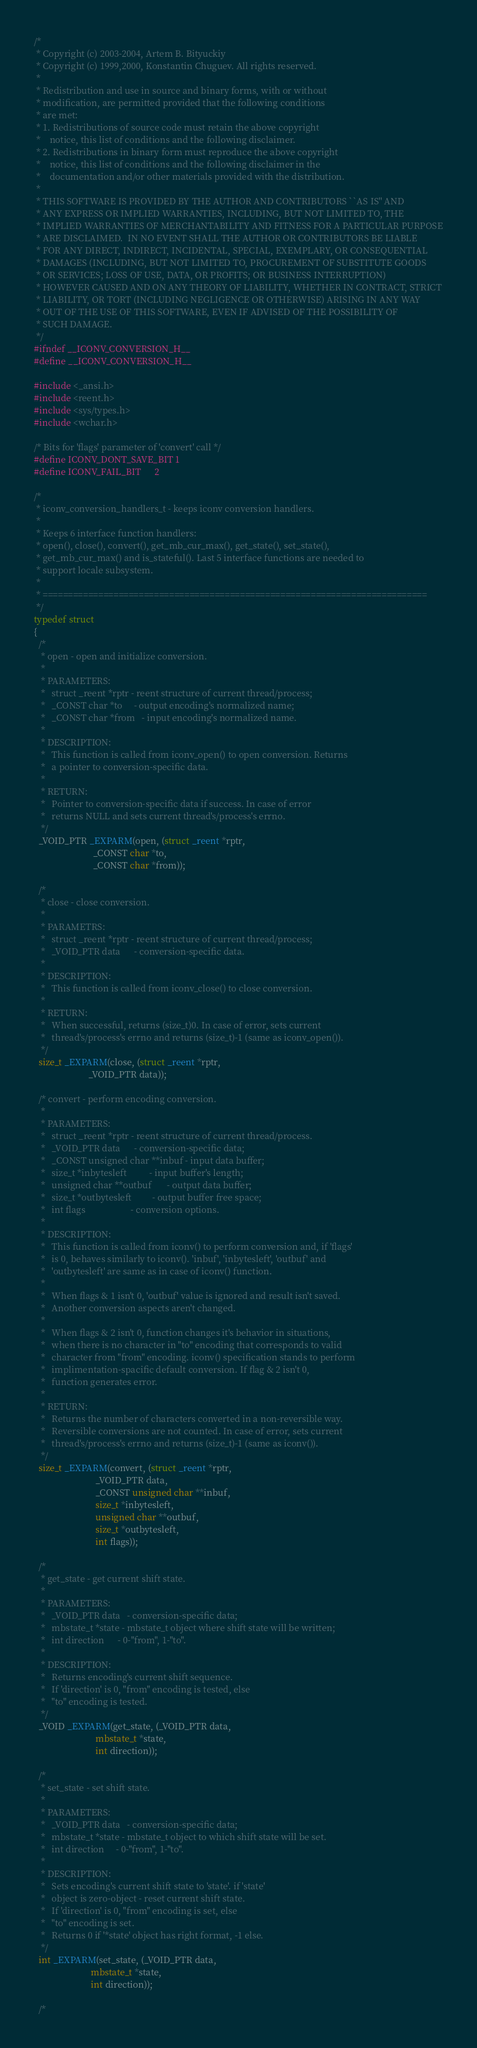<code> <loc_0><loc_0><loc_500><loc_500><_C_>/*
 * Copyright (c) 2003-2004, Artem B. Bityuckiy
 * Copyright (c) 1999,2000, Konstantin Chuguev. All rights reserved.
 *
 * Redistribution and use in source and binary forms, with or without
 * modification, are permitted provided that the following conditions
 * are met:
 * 1. Redistributions of source code must retain the above copyright
 *    notice, this list of conditions and the following disclaimer.
 * 2. Redistributions in binary form must reproduce the above copyright
 *    notice, this list of conditions and the following disclaimer in the
 *    documentation and/or other materials provided with the distribution.
 *
 * THIS SOFTWARE IS PROVIDED BY THE AUTHOR AND CONTRIBUTORS ``AS IS'' AND
 * ANY EXPRESS OR IMPLIED WARRANTIES, INCLUDING, BUT NOT LIMITED TO, THE
 * IMPLIED WARRANTIES OF MERCHANTABILITY AND FITNESS FOR A PARTICULAR PURPOSE
 * ARE DISCLAIMED.  IN NO EVENT SHALL THE AUTHOR OR CONTRIBUTORS BE LIABLE
 * FOR ANY DIRECT, INDIRECT, INCIDENTAL, SPECIAL, EXEMPLARY, OR CONSEQUENTIAL
 * DAMAGES (INCLUDING, BUT NOT LIMITED TO, PROCUREMENT OF SUBSTITUTE GOODS
 * OR SERVICES; LOSS OF USE, DATA, OR PROFITS; OR BUSINESS INTERRUPTION)
 * HOWEVER CAUSED AND ON ANY THEORY OF LIABILITY, WHETHER IN CONTRACT, STRICT
 * LIABILITY, OR TORT (INCLUDING NEGLIGENCE OR OTHERWISE) ARISING IN ANY WAY
 * OUT OF THE USE OF THIS SOFTWARE, EVEN IF ADVISED OF THE POSSIBILITY OF
 * SUCH DAMAGE.
 */
#ifndef __ICONV_CONVERSION_H__
#define __ICONV_CONVERSION_H__

#include <_ansi.h>
#include <reent.h>
#include <sys/types.h>
#include <wchar.h>

/* Bits for 'flags' parameter of 'convert' call */
#define ICONV_DONT_SAVE_BIT 1
#define ICONV_FAIL_BIT      2

/*
 * iconv_conversion_handlers_t - keeps iconv conversion handlers.
 *
 * Keeps 6 interface function handlers:
 * open(), close(), convert(), get_mb_cur_max(), get_state(), set_state(),
 * get_mb_cur_max() and is_stateful(). Last 5 interface functions are needed to
 * support locale subsystem.
 *
 * ============================================================================
 */
typedef struct
{
  /*
   * open - open and initialize conversion.
   *
   * PARAMETERS:
   *   struct _reent *rptr - reent structure of current thread/process;
   *   _CONST char *to     - output encoding's normalized name;
   *   _CONST char *from   - input encoding's normalized name.
   * 
   * DESCRIPTION:
   *   This function is called from iconv_open() to open conversion. Returns
   *   a pointer to conversion-specific data.
   *
   * RETURN:
   *   Pointer to conversion-specific data if success. In case of error
   *   returns NULL and sets current thread's/process's errno.
   */
  _VOID_PTR _EXPARM(open, (struct _reent *rptr,
                          _CONST char *to,
                          _CONST char *from));
  
  /*
   * close - close conversion.
   *
   * PARAMETRS:
   *   struct _reent *rptr - reent structure of current thread/process;
   *   _VOID_PTR data      - conversion-specific data.
   *
   * DESCRIPTION:
   *   This function is called from iconv_close() to close conversion.
   *
   * RETURN:
   *   When successful, returns (size_t)0. In case of error, sets current
   *   thread's/process's errno and returns (size_t)-1 (same as iconv_open()).
   */
  size_t _EXPARM(close, (struct _reent *rptr,
                        _VOID_PTR data));
  
  /* convert - perform encoding conversion.
   *
   * PARAMETERS:
   *   struct _reent *rptr - reent structure of current thread/process.
   *   _VOID_PTR data      - conversion-specific data;
   *   _CONST unsigned char **inbuf - input data buffer;
   *   size_t *inbytesleft          - input buffer's length;
   *   unsigned char **outbuf       - output data buffer;
   *   size_t *outbytesleft         - output buffer free space;
   *   int flags                    - conversion options.
   *
   * DESCRIPTION:
   *   This function is called from iconv() to perform conversion and, if 'flags'
   *   is 0, behaves similarly to iconv(). 'inbuf', 'inbytesleft', 'outbuf' and
   *   'outbytesleft' are same as in case of iconv() function.
   *
   *   When flags & 1 isn't 0, 'outbuf' value is ignored and result isn't saved.
   *   Another conversion aspects aren't changed.
   *
   *   When flags & 2 isn't 0, function changes it's behavior in situations,
   *   when there is no character in "to" encoding that corresponds to valid
   *   character from "from" encoding. iconv() specification stands to perform
   *   implimentation-spacific default conversion. If flag & 2 isn't 0,
   *   function generates error.
   *
   * RETURN:
   *   Returns the number of characters converted in a non-reversible way.
   *   Reversible conversions are not counted. In case of error, sets current
   *   thread's/process's errno and returns (size_t)-1 (same as iconv()).
   */
  size_t _EXPARM(convert, (struct _reent *rptr,
                           _VOID_PTR data,
                           _CONST unsigned char **inbuf,
                           size_t *inbytesleft,
                           unsigned char **outbuf,
                           size_t *outbytesleft,
                           int flags));
  
  /*
   * get_state - get current shift state.
   *
   * PARAMETERS:
   *   _VOID_PTR data   - conversion-specific data;
   *   mbstate_t *state - mbstate_t object where shift state will be written;
   *   int direction      - 0-"from", 1-"to".
   *
   * DESCRIPTION:
   *   Returns encoding's current shift sequence.
   *   If 'direction' is 0, "from" encoding is tested, else
   *   "to" encoding is tested.
   */
  _VOID _EXPARM(get_state, (_VOID_PTR data,
                           mbstate_t *state,
                           int direction));

  /*
   * set_state - set shift state.
   *
   * PARAMETERS:
   *   _VOID_PTR data   - conversion-specific data;
   *   mbstate_t *state - mbstate_t object to which shift state will be set.
   *   int direction     - 0-"from", 1-"to".
   *
   * DESCRIPTION:
   *   Sets encoding's current shift state to 'state'. if 'state'
   *   object is zero-object - reset current shift state.
   *   If 'direction' is 0, "from" encoding is set, else
   *   "to" encoding is set.
   *   Returns 0 if '*state' object has right format, -1 else.
   */
  int _EXPARM(set_state, (_VOID_PTR data,
                         mbstate_t *state,
                         int direction));
  
  /*</code> 